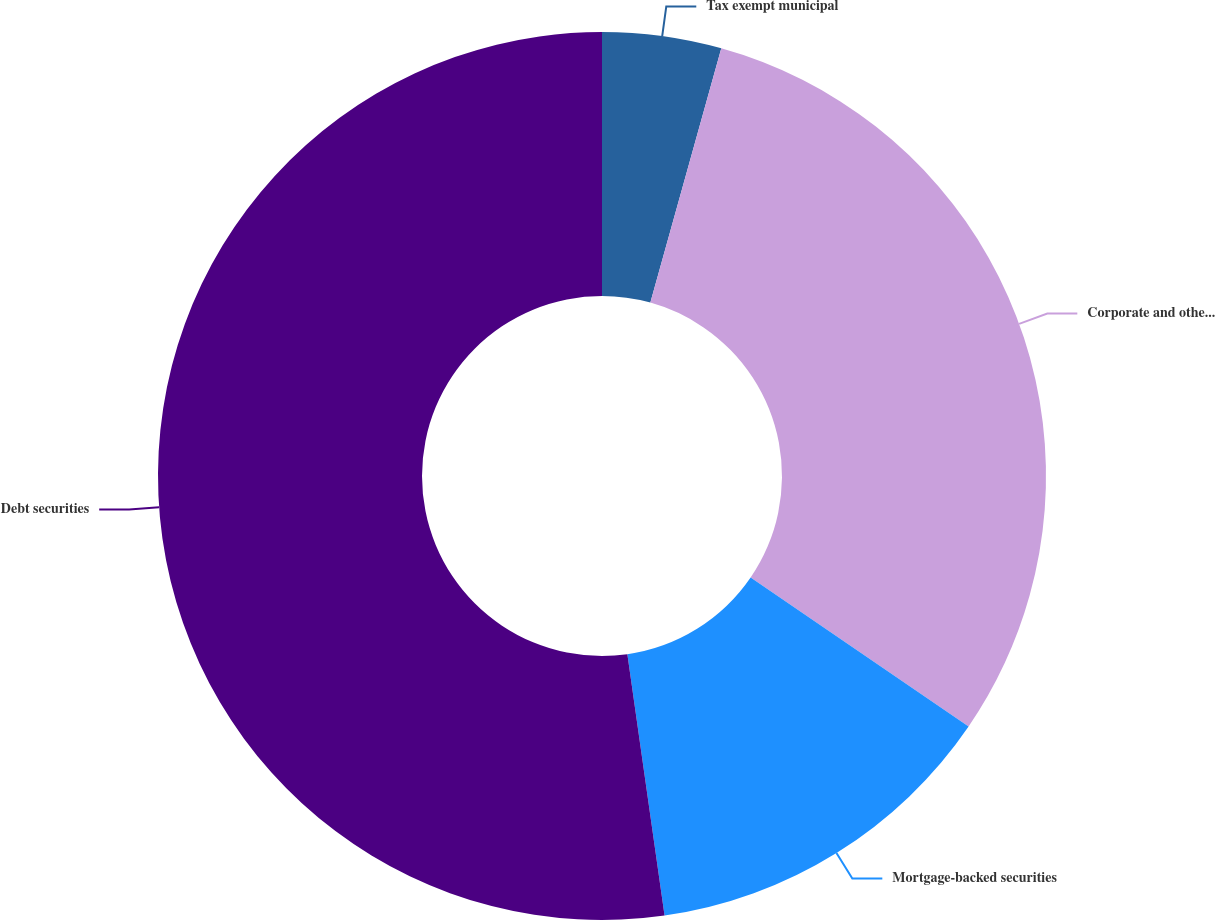Convert chart. <chart><loc_0><loc_0><loc_500><loc_500><pie_chart><fcel>Tax exempt municipal<fcel>Corporate and other securities<fcel>Mortgage-backed securities<fcel>Debt securities<nl><fcel>4.33%<fcel>30.21%<fcel>13.21%<fcel>52.25%<nl></chart> 